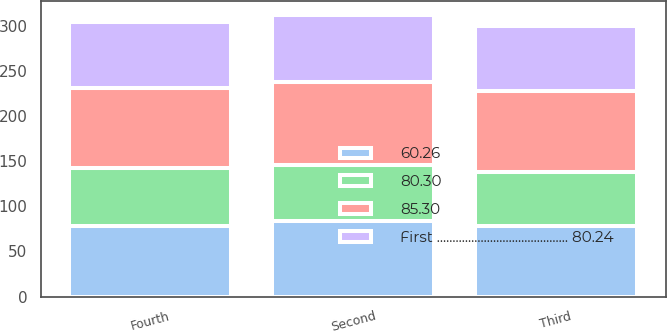Convert chart. <chart><loc_0><loc_0><loc_500><loc_500><stacked_bar_chart><ecel><fcel>Second<fcel>Third<fcel>Fourth<nl><fcel>First .......................................... 80.24<fcel>74.15<fcel>71.71<fcel>73.6<nl><fcel>80.30<fcel>61.57<fcel>60.48<fcel>63.75<nl><fcel>85.30<fcel>92.34<fcel>89.4<fcel>88.49<nl><fcel>60.26<fcel>84.03<fcel>77.93<fcel>78.71<nl></chart> 